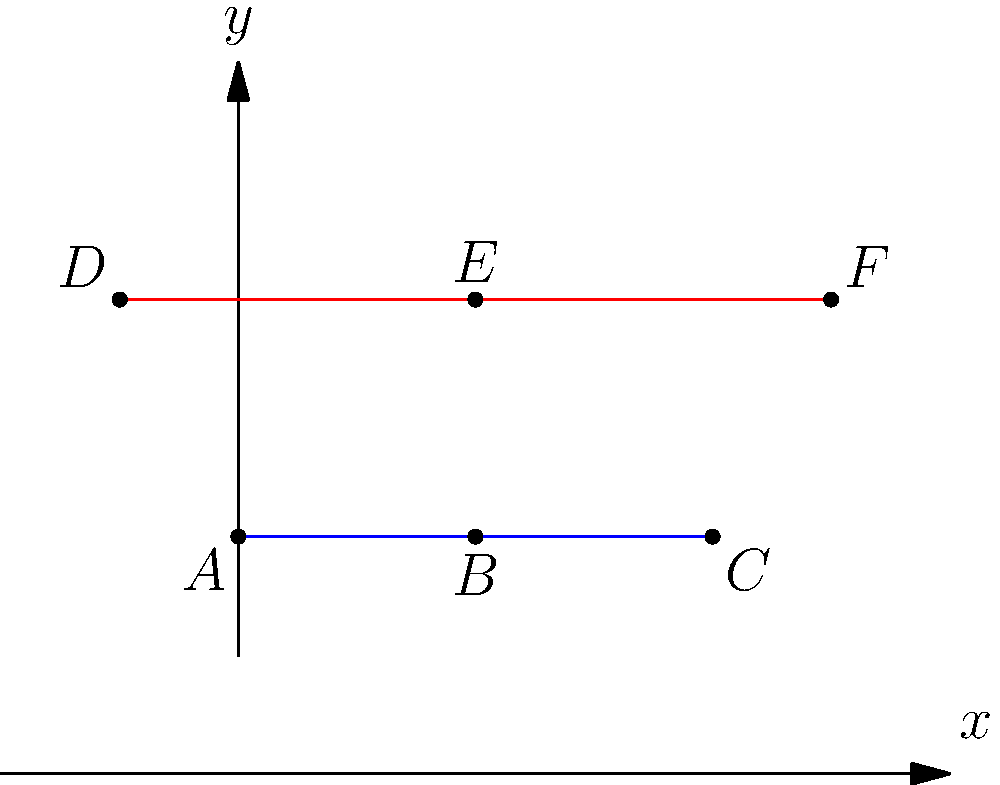In the upper half-plane model of hyperbolic geometry, two lines are drawn as shown in the figure. Line $\overline{ABC}$ is a straight Euclidean line, while $\overline{DEF}$ is an arc of a circle centered on the x-axis. According to the principles of hyperbolic geometry, what is the relationship between these two lines? To understand the relationship between these lines in hyperbolic geometry, let's follow these steps:

1) In the upper half-plane model of hyperbolic geometry, "straight" lines are represented by either:
   a) Vertical Euclidean lines perpendicular to the x-axis
   b) Semicircles with centers on the x-axis

2) In our figure, $\overline{ABC}$ is a horizontal Euclidean line, which in hyperbolic geometry represents a semicircle with an infinite radius centered at infinity on the x-axis.

3) $\overline{DEF}$ is visibly an arc of a circle centered on the x-axis.

4) Both of these lines satisfy the definition of "straight" lines in hyperbolic geometry.

5) In Euclidean geometry, these lines would eventually intersect if extended. However, in hyperbolic geometry, they do not.

6) The key principle here is that in hyperbolic geometry, through a point not on a given line, there are infinitely many lines parallel to the given line.

7) Therefore, even though these lines appear to be converging, they are actually parallel in hyperbolic geometry. They will never intersect, no matter how far they are extended.

This concept might seem counterintuitive to our Euclidean-trained minds, but it's a fundamental property of hyperbolic geometry, reflecting the negative curvature of the hyperbolic plane.
Answer: The lines are parallel in hyperbolic geometry. 